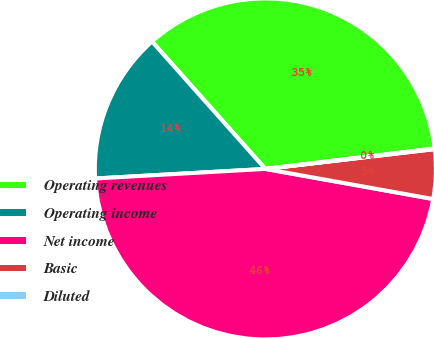<chart> <loc_0><loc_0><loc_500><loc_500><pie_chart><fcel>Operating revenues<fcel>Operating income<fcel>Net income<fcel>Basic<fcel>Diluted<nl><fcel>34.66%<fcel>14.32%<fcel>46.28%<fcel>4.68%<fcel>0.06%<nl></chart> 